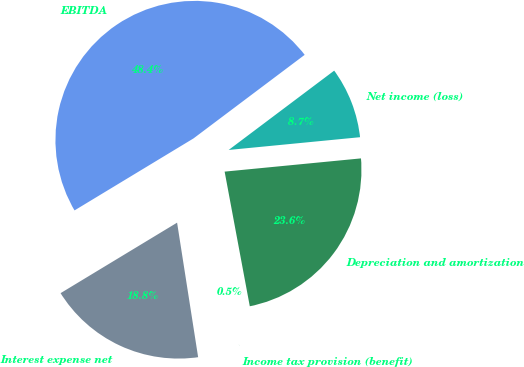Convert chart. <chart><loc_0><loc_0><loc_500><loc_500><pie_chart><fcel>EBITDA<fcel>Interest expense net<fcel>Income tax provision (benefit)<fcel>Depreciation and amortization<fcel>Net income (loss)<nl><fcel>48.4%<fcel>18.81%<fcel>0.47%<fcel>23.6%<fcel>8.72%<nl></chart> 